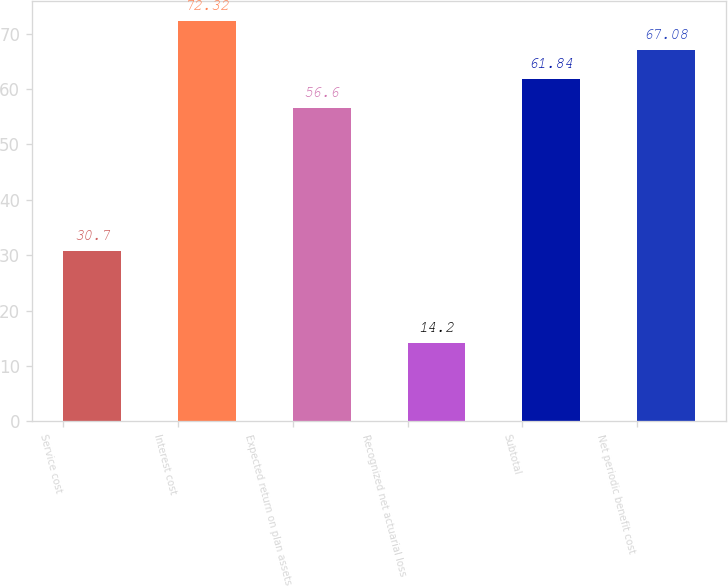Convert chart to OTSL. <chart><loc_0><loc_0><loc_500><loc_500><bar_chart><fcel>Service cost<fcel>Interest cost<fcel>Expected return on plan assets<fcel>Recognized net actuarial loss<fcel>Subtotal<fcel>Net periodic benefit cost<nl><fcel>30.7<fcel>72.32<fcel>56.6<fcel>14.2<fcel>61.84<fcel>67.08<nl></chart> 